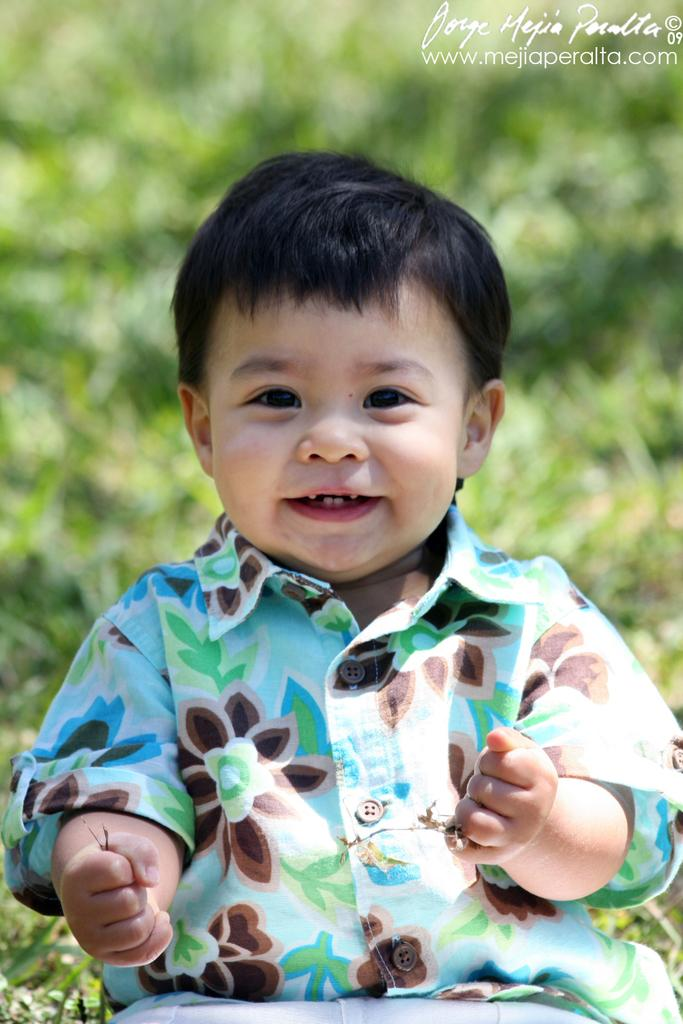Who is present in the image? There is a boy in the image. What is the boy doing in the image? The boy is smiling in the image. Where is the boy sitting in the image? The boy is sitting on the grass in the image. What can be seen at the top of the image? There is a logo visible at the top of the image. What type of brass instrument is the boy playing in the image? There is no brass instrument present in the image; the boy is simply sitting on the grass and smiling. 